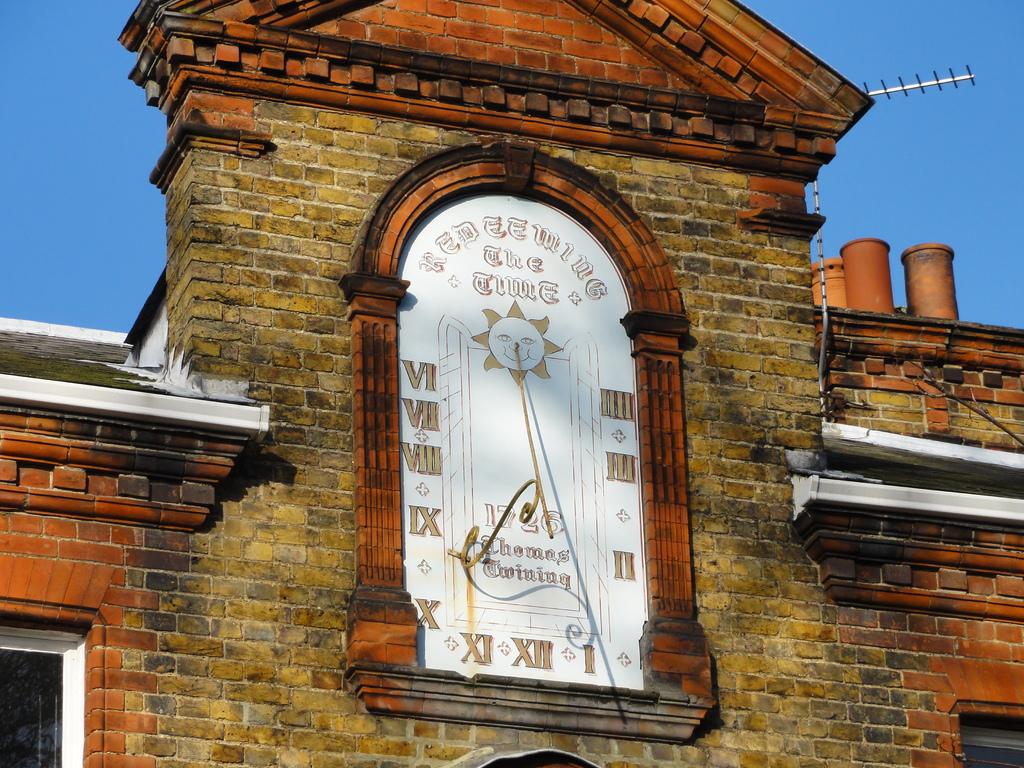What it the top left number?
Offer a terse response. 6. 